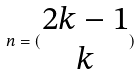<formula> <loc_0><loc_0><loc_500><loc_500>n = ( \begin{matrix} 2 k - 1 \\ k \end{matrix} )</formula> 